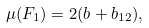Convert formula to latex. <formula><loc_0><loc_0><loc_500><loc_500>\mu ( F _ { 1 } ) = 2 ( b + b _ { 1 2 } ) ,</formula> 